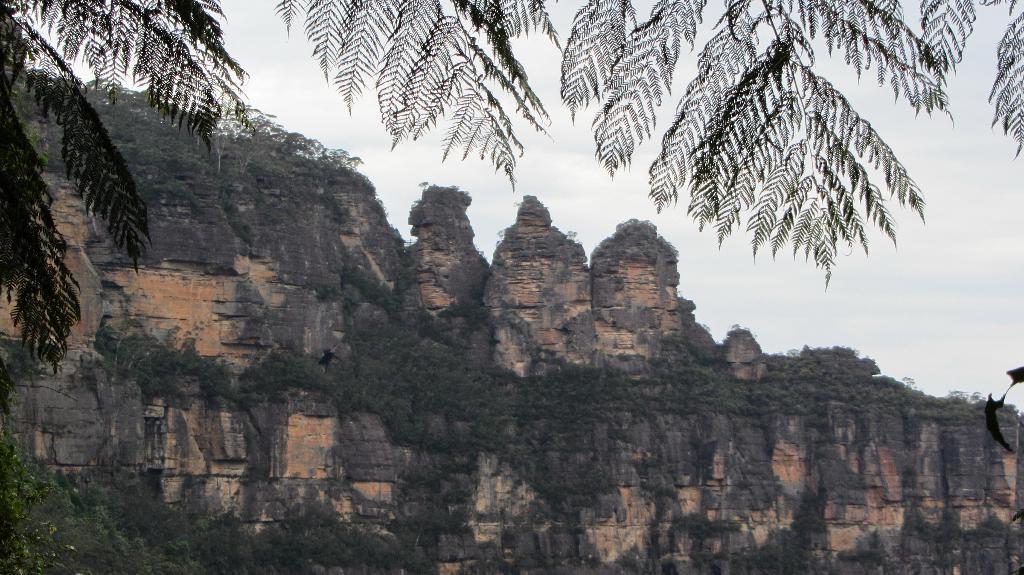Please provide a concise description of this image. In this image I can see trees in the front. In the background I can see rocky mountains and the sky. 